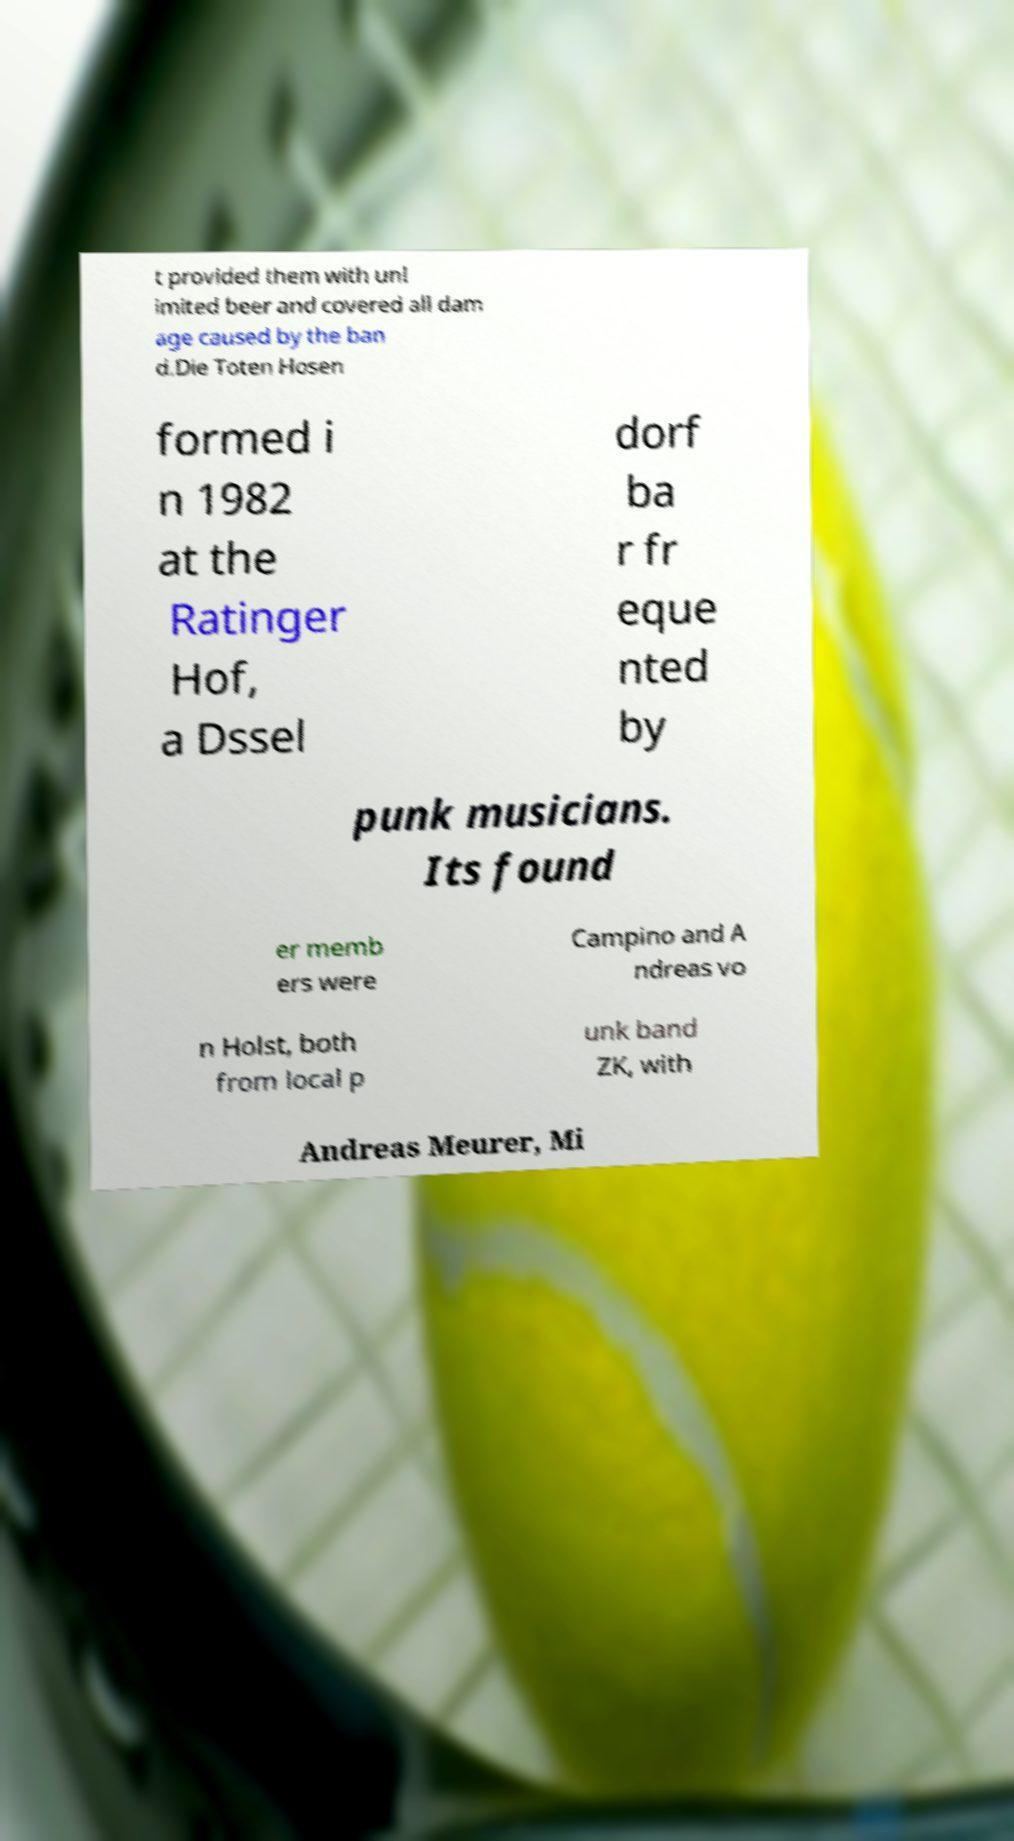For documentation purposes, I need the text within this image transcribed. Could you provide that? t provided them with unl imited beer and covered all dam age caused by the ban d.Die Toten Hosen formed i n 1982 at the Ratinger Hof, a Dssel dorf ba r fr eque nted by punk musicians. Its found er memb ers were Campino and A ndreas vo n Holst, both from local p unk band ZK, with Andreas Meurer, Mi 